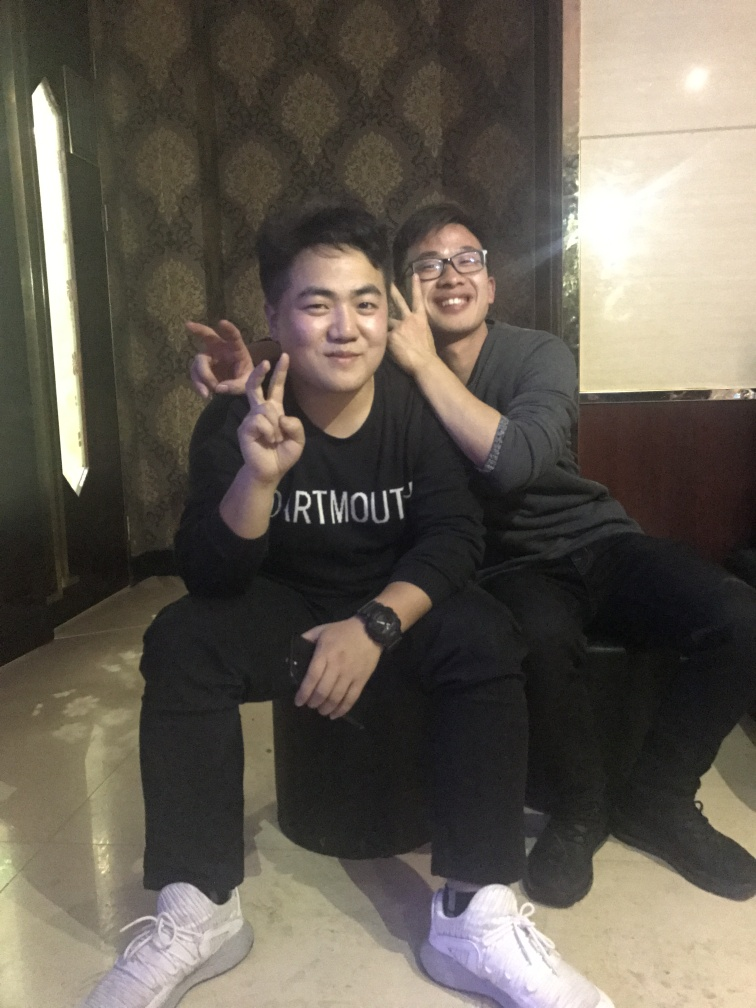Is the main subject, the person being photographed, quite clear?
 Yes 